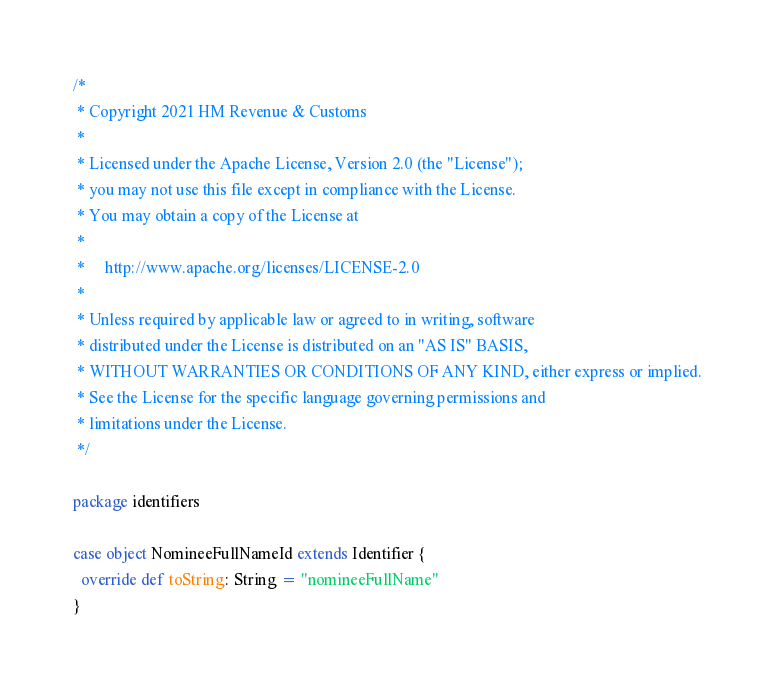<code> <loc_0><loc_0><loc_500><loc_500><_Scala_>/*
 * Copyright 2021 HM Revenue & Customs
 *
 * Licensed under the Apache License, Version 2.0 (the "License");
 * you may not use this file except in compliance with the License.
 * You may obtain a copy of the License at
 *
 *     http://www.apache.org/licenses/LICENSE-2.0
 *
 * Unless required by applicable law or agreed to in writing, software
 * distributed under the License is distributed on an "AS IS" BASIS,
 * WITHOUT WARRANTIES OR CONDITIONS OF ANY KIND, either express or implied.
 * See the License for the specific language governing permissions and
 * limitations under the License.
 */

package identifiers

case object NomineeFullNameId extends Identifier {
  override def toString: String = "nomineeFullName"
}
</code> 